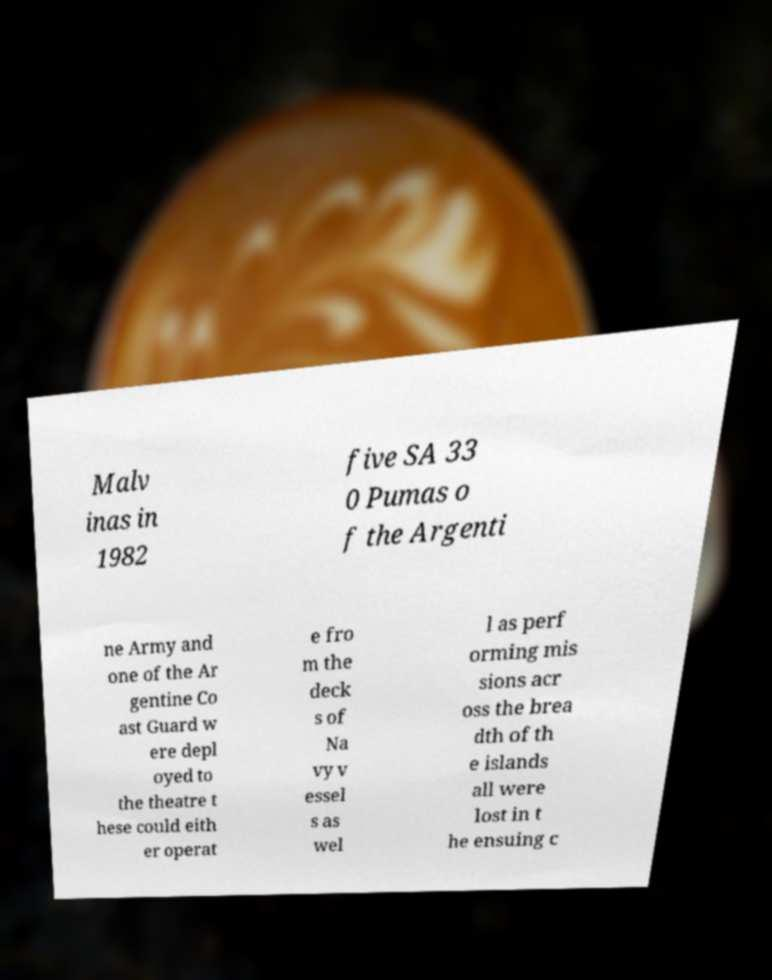Can you accurately transcribe the text from the provided image for me? Malv inas in 1982 five SA 33 0 Pumas o f the Argenti ne Army and one of the Ar gentine Co ast Guard w ere depl oyed to the theatre t hese could eith er operat e fro m the deck s of Na vy v essel s as wel l as perf orming mis sions acr oss the brea dth of th e islands all were lost in t he ensuing c 